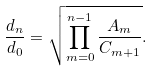<formula> <loc_0><loc_0><loc_500><loc_500>\frac { d _ { n } } { d _ { 0 } } = \sqrt { \prod _ { m = 0 } ^ { n - 1 } \frac { A _ { m } } { C _ { m + 1 } } } .</formula> 